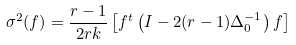Convert formula to latex. <formula><loc_0><loc_0><loc_500><loc_500>\sigma ^ { 2 } ( f ) = \frac { r - 1 } { 2 r k } \left [ f ^ { t } \left ( I - 2 ( r - 1 ) \Delta _ { 0 } ^ { - 1 } \right ) f \right ]</formula> 